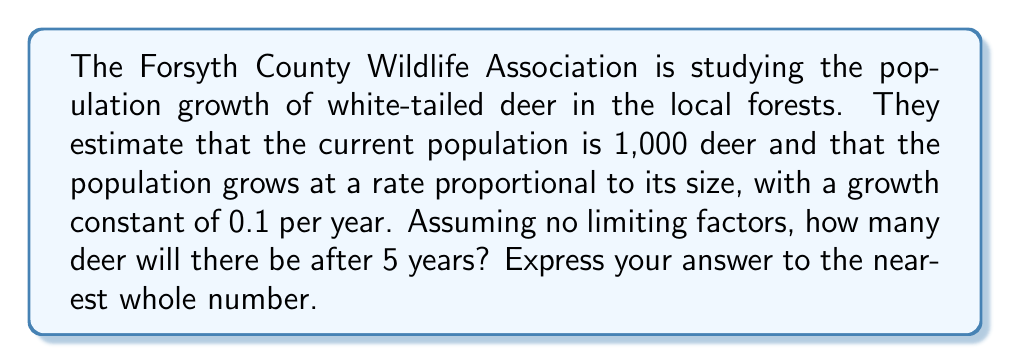What is the answer to this math problem? To solve this problem, we need to use the exponential growth model, which is a first-order differential equation. The model is given by:

$$\frac{dP}{dt} = kP$$

Where:
- $P$ is the population size
- $t$ is time
- $k$ is the growth constant

The solution to this differential equation is:

$$P(t) = P_0e^{kt}$$

Where $P_0$ is the initial population size.

Given:
- Initial population, $P_0 = 1,000$ deer
- Growth constant, $k = 0.1$ per year
- Time, $t = 5$ years

Let's substitute these values into our equation:

$$P(5) = 1000e^{0.1 \cdot 5}$$

Now, let's calculate:

$$\begin{align*}
P(5) &= 1000e^{0.5} \\
&= 1000 \cdot (1.6487...) \\
&= 1648.7...
\end{align*}$$

Rounding to the nearest whole number, we get 1,649 deer.
Answer: 1,649 deer 